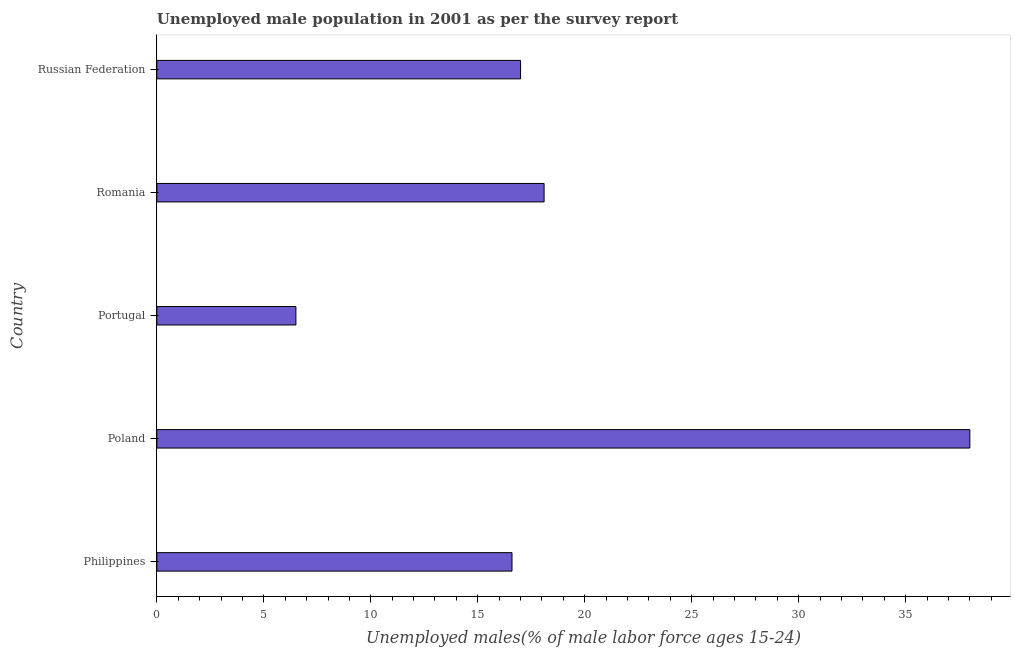What is the title of the graph?
Provide a succinct answer. Unemployed male population in 2001 as per the survey report. What is the label or title of the X-axis?
Give a very brief answer. Unemployed males(% of male labor force ages 15-24). What is the unemployed male youth in Romania?
Provide a short and direct response. 18.1. Across all countries, what is the maximum unemployed male youth?
Keep it short and to the point. 38. In which country was the unemployed male youth maximum?
Your response must be concise. Poland. In which country was the unemployed male youth minimum?
Keep it short and to the point. Portugal. What is the sum of the unemployed male youth?
Give a very brief answer. 96.2. What is the average unemployed male youth per country?
Give a very brief answer. 19.24. What is the median unemployed male youth?
Your answer should be compact. 17. In how many countries, is the unemployed male youth greater than 8 %?
Offer a very short reply. 4. What is the ratio of the unemployed male youth in Romania to that in Russian Federation?
Offer a very short reply. 1.06. Is the difference between the unemployed male youth in Romania and Russian Federation greater than the difference between any two countries?
Give a very brief answer. No. What is the difference between the highest and the second highest unemployed male youth?
Your answer should be very brief. 19.9. Is the sum of the unemployed male youth in Poland and Portugal greater than the maximum unemployed male youth across all countries?
Give a very brief answer. Yes. What is the difference between the highest and the lowest unemployed male youth?
Provide a succinct answer. 31.5. In how many countries, is the unemployed male youth greater than the average unemployed male youth taken over all countries?
Your response must be concise. 1. Are the values on the major ticks of X-axis written in scientific E-notation?
Your answer should be very brief. No. What is the Unemployed males(% of male labor force ages 15-24) in Philippines?
Provide a short and direct response. 16.6. What is the Unemployed males(% of male labor force ages 15-24) of Poland?
Offer a terse response. 38. What is the Unemployed males(% of male labor force ages 15-24) in Portugal?
Offer a terse response. 6.5. What is the Unemployed males(% of male labor force ages 15-24) in Romania?
Give a very brief answer. 18.1. What is the difference between the Unemployed males(% of male labor force ages 15-24) in Philippines and Poland?
Provide a short and direct response. -21.4. What is the difference between the Unemployed males(% of male labor force ages 15-24) in Philippines and Portugal?
Offer a very short reply. 10.1. What is the difference between the Unemployed males(% of male labor force ages 15-24) in Poland and Portugal?
Offer a very short reply. 31.5. What is the difference between the Unemployed males(% of male labor force ages 15-24) in Poland and Romania?
Keep it short and to the point. 19.9. What is the difference between the Unemployed males(% of male labor force ages 15-24) in Portugal and Romania?
Keep it short and to the point. -11.6. What is the difference between the Unemployed males(% of male labor force ages 15-24) in Portugal and Russian Federation?
Provide a succinct answer. -10.5. What is the ratio of the Unemployed males(% of male labor force ages 15-24) in Philippines to that in Poland?
Offer a very short reply. 0.44. What is the ratio of the Unemployed males(% of male labor force ages 15-24) in Philippines to that in Portugal?
Provide a succinct answer. 2.55. What is the ratio of the Unemployed males(% of male labor force ages 15-24) in Philippines to that in Romania?
Provide a short and direct response. 0.92. What is the ratio of the Unemployed males(% of male labor force ages 15-24) in Poland to that in Portugal?
Ensure brevity in your answer.  5.85. What is the ratio of the Unemployed males(% of male labor force ages 15-24) in Poland to that in Romania?
Keep it short and to the point. 2.1. What is the ratio of the Unemployed males(% of male labor force ages 15-24) in Poland to that in Russian Federation?
Ensure brevity in your answer.  2.23. What is the ratio of the Unemployed males(% of male labor force ages 15-24) in Portugal to that in Romania?
Your answer should be compact. 0.36. What is the ratio of the Unemployed males(% of male labor force ages 15-24) in Portugal to that in Russian Federation?
Provide a succinct answer. 0.38. What is the ratio of the Unemployed males(% of male labor force ages 15-24) in Romania to that in Russian Federation?
Make the answer very short. 1.06. 